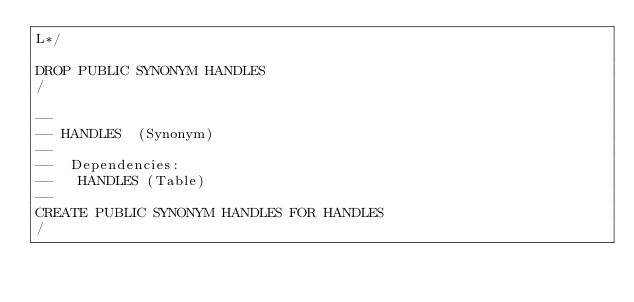Convert code to text. <code><loc_0><loc_0><loc_500><loc_500><_SQL_>L*/

DROP PUBLIC SYNONYM HANDLES
/

--
-- HANDLES  (Synonym) 
--
--  Dependencies: 
--   HANDLES (Table)
--
CREATE PUBLIC SYNONYM HANDLES FOR HANDLES
/


</code> 